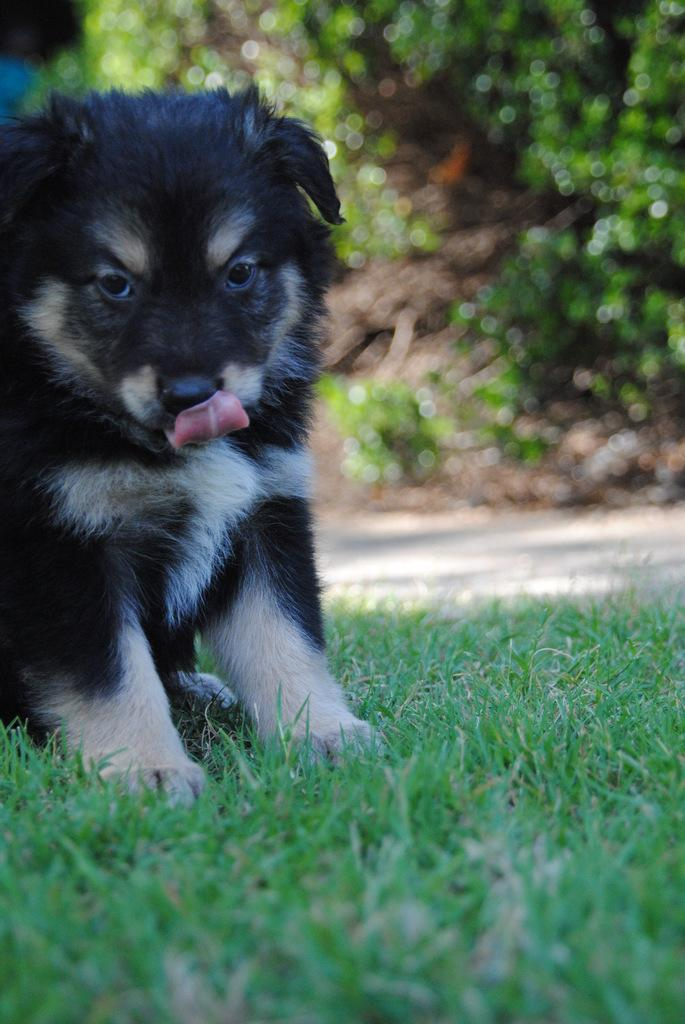What animal is present in the image? There is a dog in the image. What is the dog doing in the image? The dog is sitting on the grass. Can you describe the background of the image? The background of the image appears blurry. What type of church can be seen in the background of the image? There is no church present in the image; it features a dog sitting on the grass with a blurry background. What type of bone is the dog chewing on in the image? There is no bone present in the image; the dog is simply sitting on the grass. 